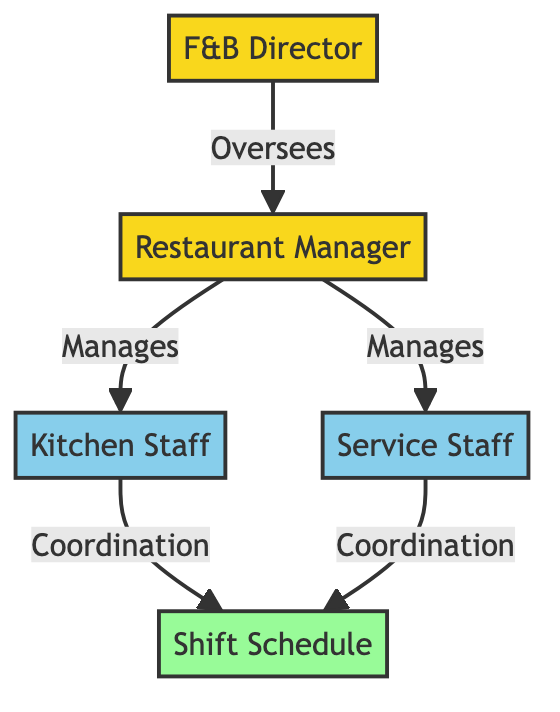What is the highest position in the diagram? The diagram shows the hierarchy of positions, with "F&B Director" at the top as the highest position overseeing the operations.
Answer: F&B Director How many departments are managed by the Restaurant Manager? According to the diagram, the Restaurant Manager manages two departments: Kitchen Staff and Service Staff.
Answer: 2 What role does the F&B Director play in the scheduling process? The diagram indicates that the F&B Director oversees the Restaurant Manager, who then coordinates with departments contributing to the Shift Schedule, highlighting the Director's supervisory role.
Answer: Oversees Which staff member is connected to both coordinating elements in the diagram? The Kitchen Staff and Service Staff both connect to the Shift Schedule through coordination, representing their involvement in creating the schedule.
Answer: Both Kitchen Staff and Service Staff How many nodes represent staff roles in the diagram? The diagram consists of four nodes representing roles, including the Restaurant Manager, Kitchen Staff, Service Staff, and the F&B Director, which totals four.
Answer: 4 What does the link between the Restaurant Manager and the Shift Schedule imply? The link implies that the Restaurant Manager has a direct responsibility for coordinating with both departments (Kitchen Staff and Service Staff) to manage the Shift Schedule effectively.
Answer: Coordination Which position manages the two staff departments? The diagram clearly states that the Restaurant Manager manages both the Kitchen Staff and the Service Staff departments under its supervision.
Answer: Restaurant Manager In what way does the Kitchen Staff engage in the scheduling process? The Kitchen Staff engages by coordinating with the Shift Schedule, as depicted in the diagram, indicating their active involvement in scheduling.
Answer: Coordination 